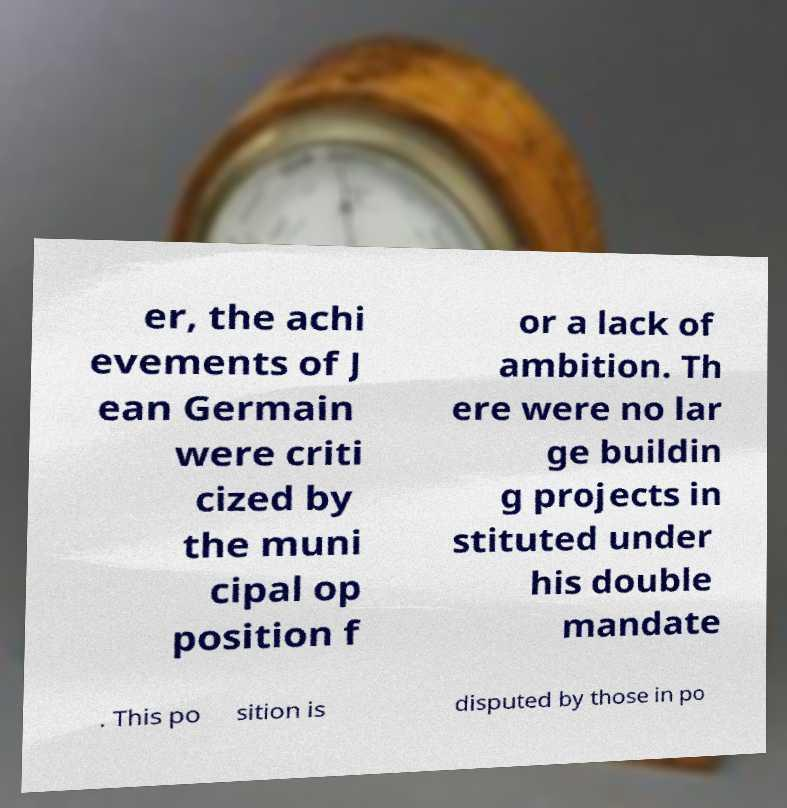Please read and relay the text visible in this image. What does it say? er, the achi evements of J ean Germain were criti cized by the muni cipal op position f or a lack of ambition. Th ere were no lar ge buildin g projects in stituted under his double mandate . This po sition is disputed by those in po 